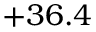<formula> <loc_0><loc_0><loc_500><loc_500>+ 3 6 . 4</formula> 